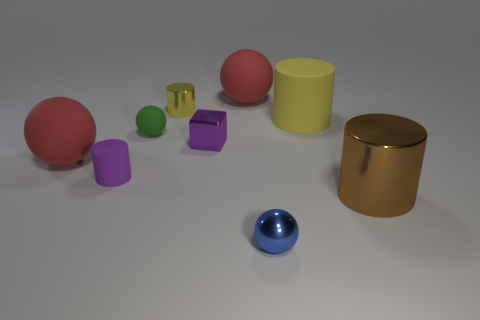How many tiny objects are metal cubes or cylinders?
Ensure brevity in your answer.  3. There is a rubber ball that is both in front of the tiny yellow shiny thing and to the right of the purple cylinder; how big is it?
Your response must be concise. Small. There is a blue thing; how many small yellow shiny objects are on the right side of it?
Your answer should be very brief. 0. The small shiny object that is behind the blue metallic ball and to the right of the yellow shiny object has what shape?
Provide a succinct answer. Cube. What material is the cylinder that is the same color as the cube?
Provide a succinct answer. Rubber. What number of spheres are either tiny blue metal objects or big red matte objects?
Your response must be concise. 3. What is the size of the matte cylinder that is the same color as the tiny metallic cube?
Your answer should be compact. Small. Are there fewer small green balls that are right of the big yellow thing than metal cylinders?
Provide a short and direct response. Yes. There is a large rubber thing that is behind the purple metallic block and to the left of the yellow rubber object; what color is it?
Provide a short and direct response. Red. How many other objects are the same shape as the yellow metallic thing?
Provide a short and direct response. 3. 